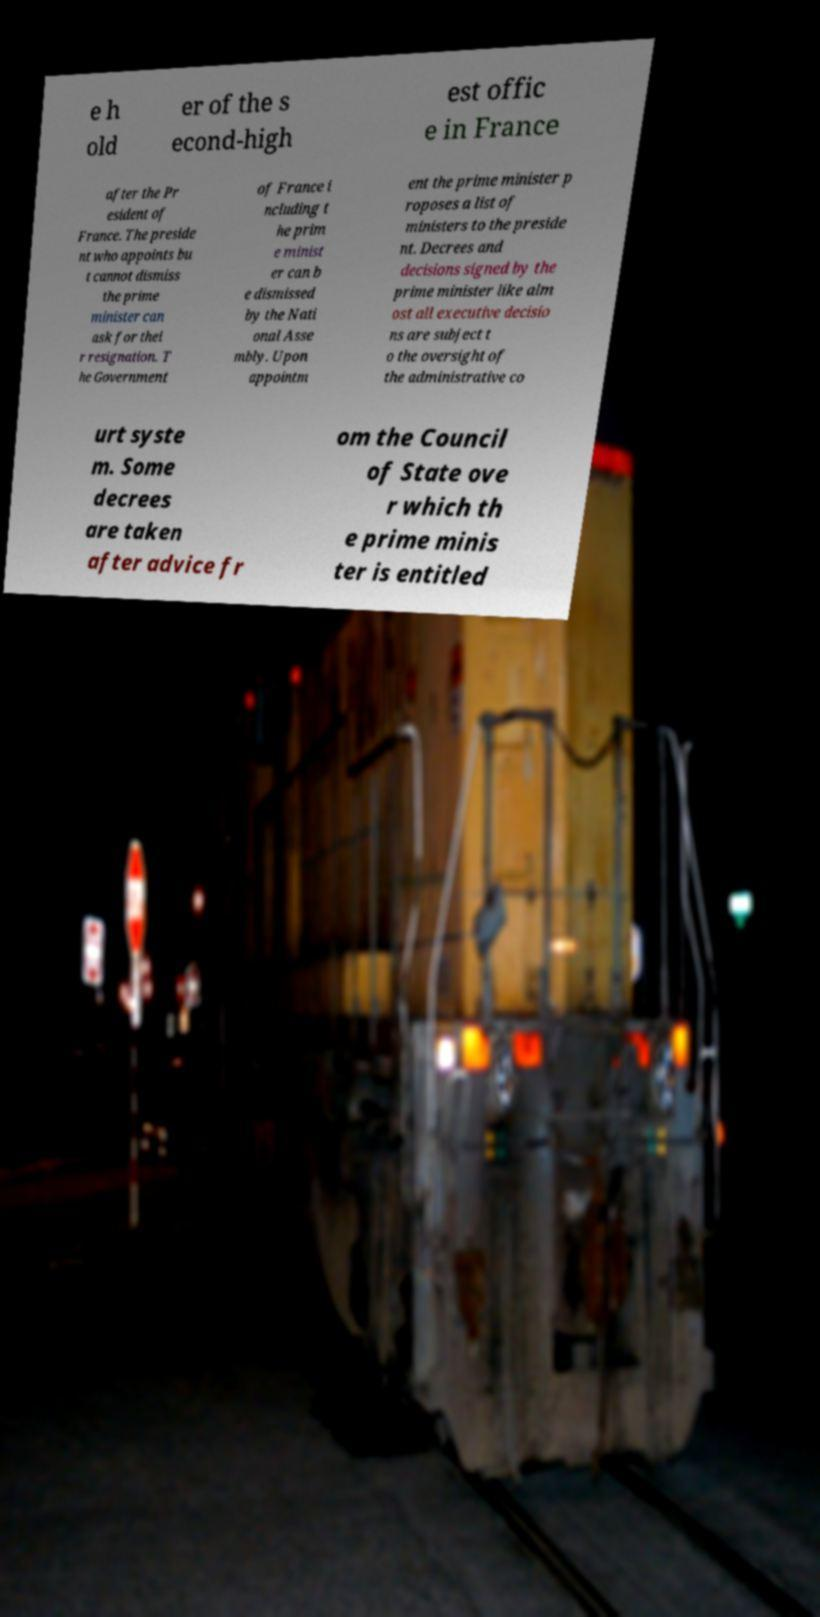Please read and relay the text visible in this image. What does it say? e h old er of the s econd-high est offic e in France after the Pr esident of France. The preside nt who appoints bu t cannot dismiss the prime minister can ask for thei r resignation. T he Government of France i ncluding t he prim e minist er can b e dismissed by the Nati onal Asse mbly. Upon appointm ent the prime minister p roposes a list of ministers to the preside nt. Decrees and decisions signed by the prime minister like alm ost all executive decisio ns are subject t o the oversight of the administrative co urt syste m. Some decrees are taken after advice fr om the Council of State ove r which th e prime minis ter is entitled 